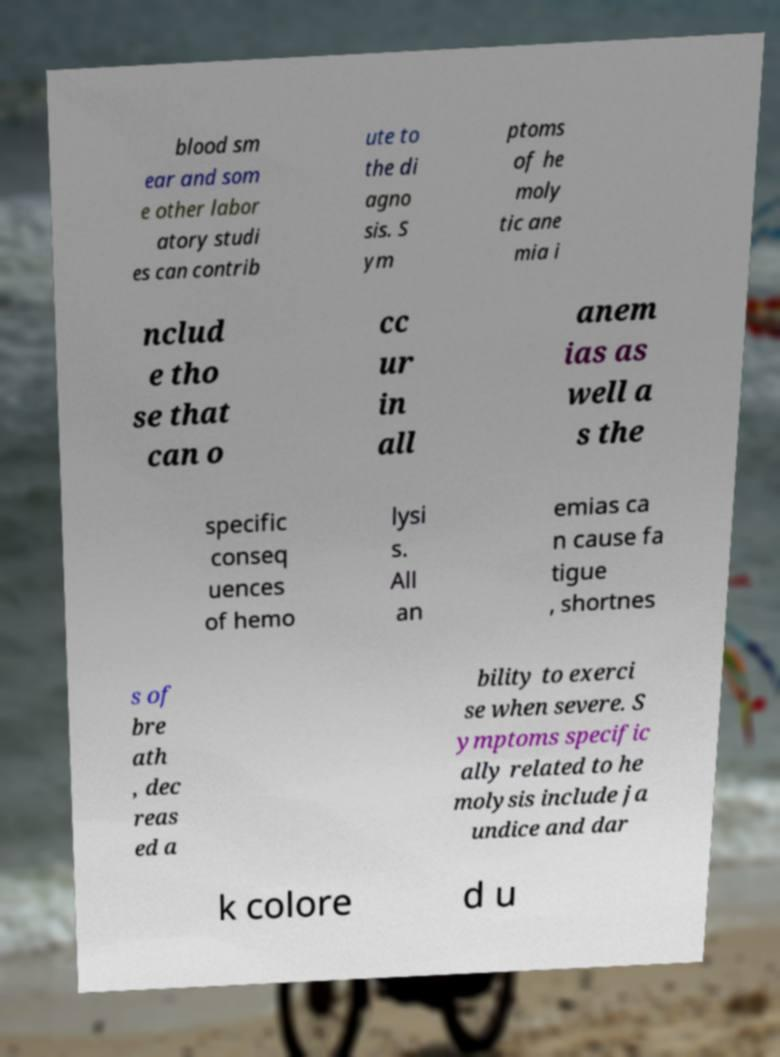I need the written content from this picture converted into text. Can you do that? blood sm ear and som e other labor atory studi es can contrib ute to the di agno sis. S ym ptoms of he moly tic ane mia i nclud e tho se that can o cc ur in all anem ias as well a s the specific conseq uences of hemo lysi s. All an emias ca n cause fa tigue , shortnes s of bre ath , dec reas ed a bility to exerci se when severe. S ymptoms specific ally related to he molysis include ja undice and dar k colore d u 